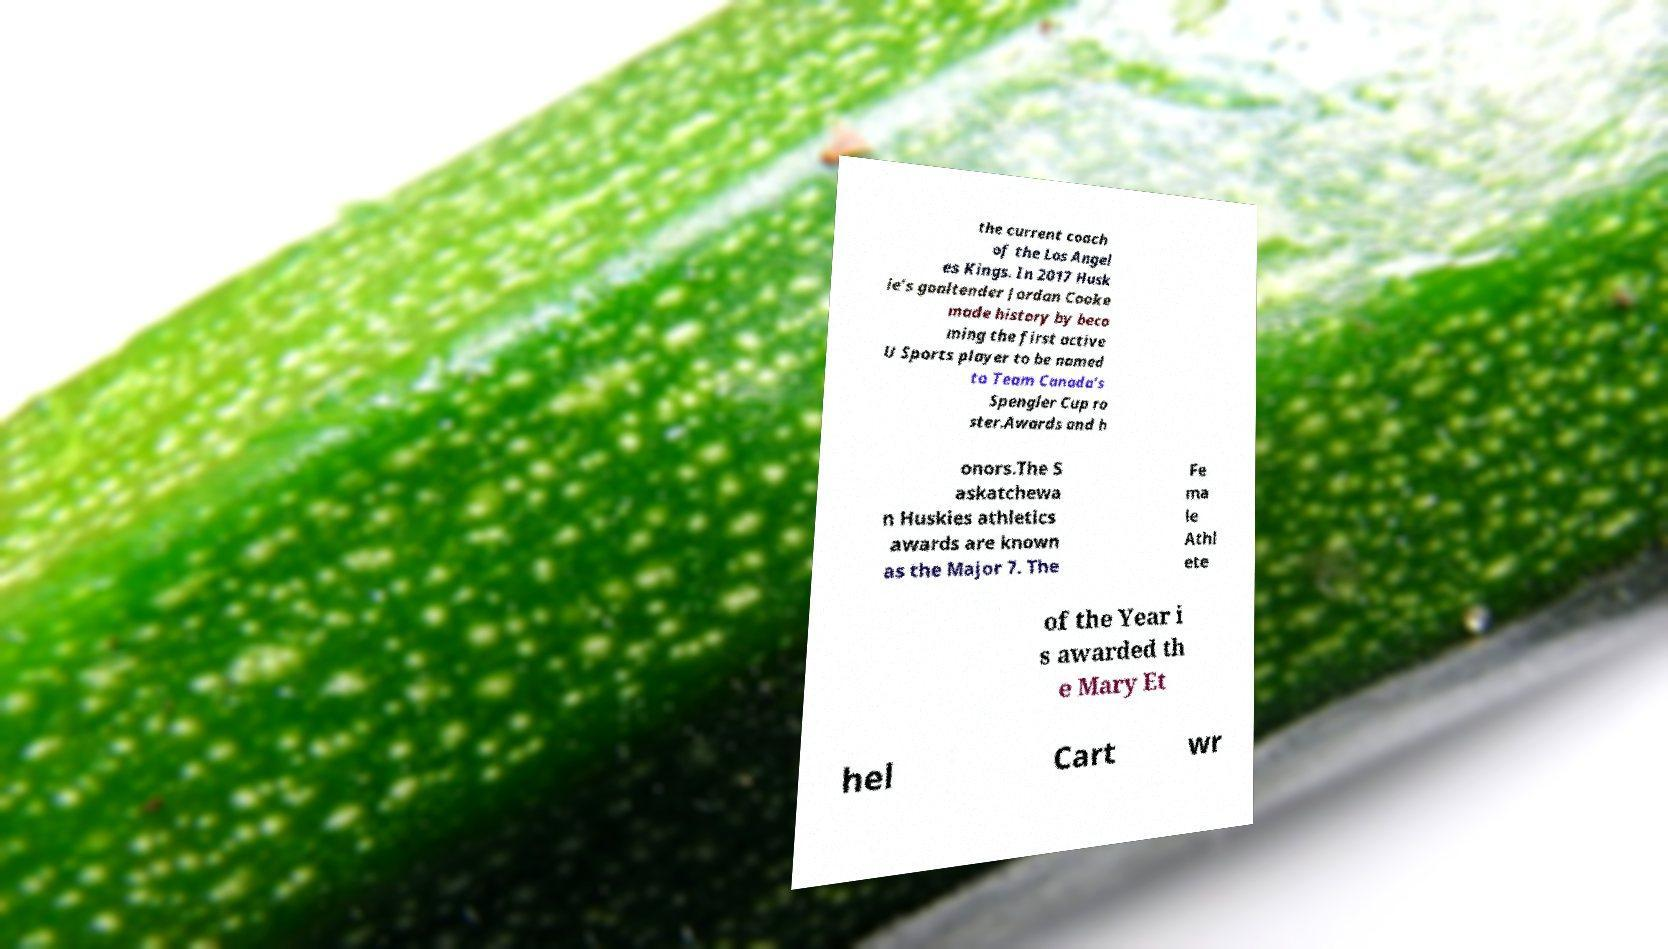For documentation purposes, I need the text within this image transcribed. Could you provide that? the current coach of the Los Angel es Kings. In 2017 Husk ie’s goaltender Jordan Cooke made history by beco ming the first active U Sports player to be named to Team Canada’s Spengler Cup ro ster.Awards and h onors.The S askatchewa n Huskies athletics awards are known as the Major 7. The Fe ma le Athl ete of the Year i s awarded th e Mary Et hel Cart wr 